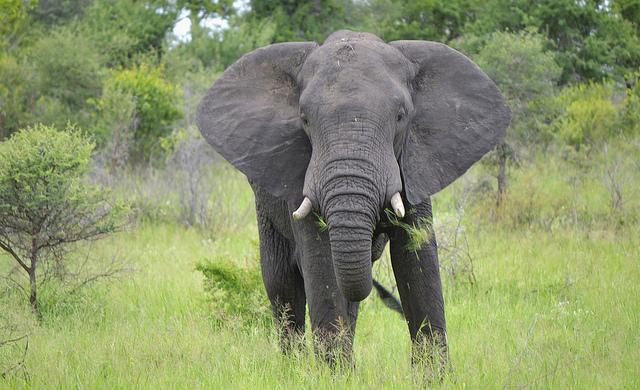How many elephants are there?
Give a very brief answer. 1. How many elephants in the scene?
Give a very brief answer. 1. 